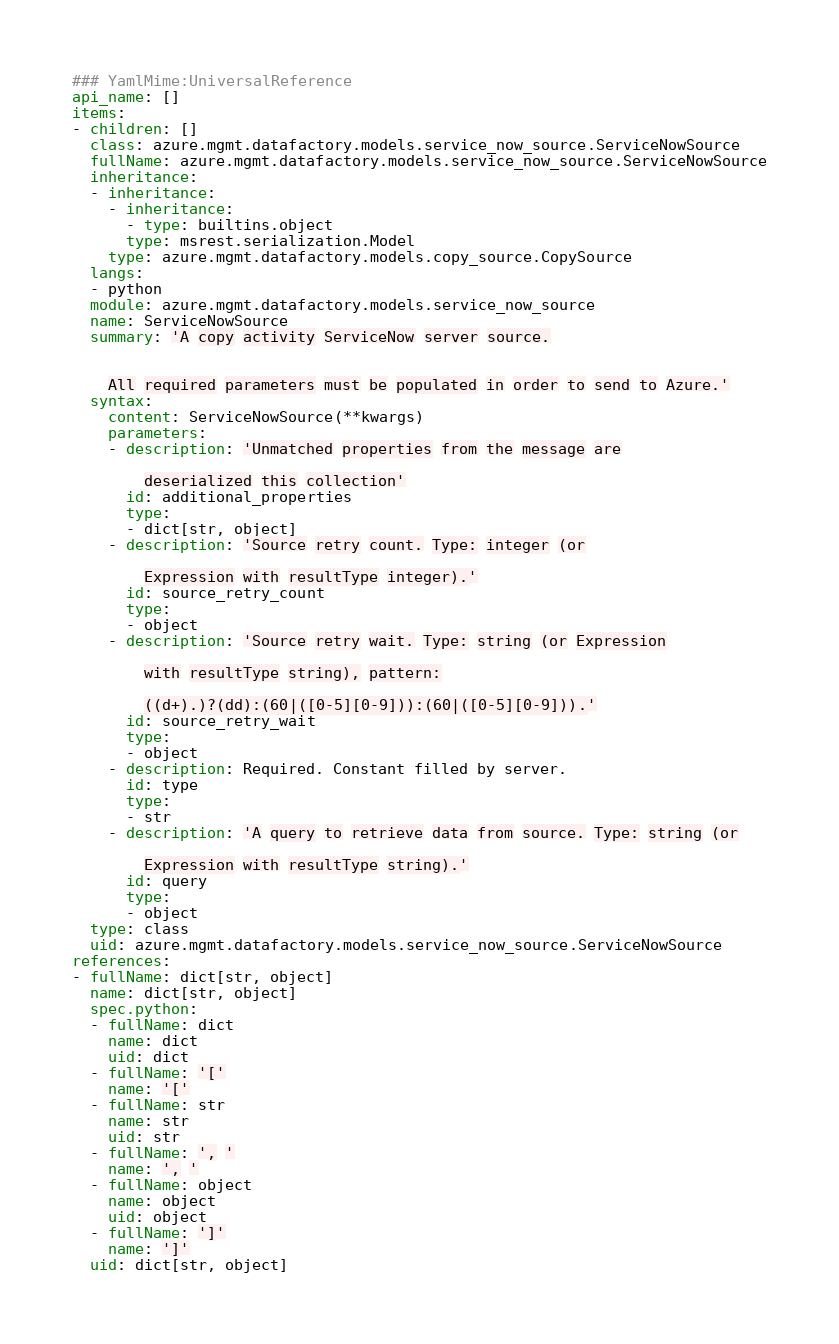<code> <loc_0><loc_0><loc_500><loc_500><_YAML_>### YamlMime:UniversalReference
api_name: []
items:
- children: []
  class: azure.mgmt.datafactory.models.service_now_source.ServiceNowSource
  fullName: azure.mgmt.datafactory.models.service_now_source.ServiceNowSource
  inheritance:
  - inheritance:
    - inheritance:
      - type: builtins.object
      type: msrest.serialization.Model
    type: azure.mgmt.datafactory.models.copy_source.CopySource
  langs:
  - python
  module: azure.mgmt.datafactory.models.service_now_source
  name: ServiceNowSource
  summary: 'A copy activity ServiceNow server source.


    All required parameters must be populated in order to send to Azure.'
  syntax:
    content: ServiceNowSource(**kwargs)
    parameters:
    - description: 'Unmatched properties from the message are

        deserialized this collection'
      id: additional_properties
      type:
      - dict[str, object]
    - description: 'Source retry count. Type: integer (or

        Expression with resultType integer).'
      id: source_retry_count
      type:
      - object
    - description: 'Source retry wait. Type: string (or Expression

        with resultType string), pattern:

        ((d+).)?(dd):(60|([0-5][0-9])):(60|([0-5][0-9])).'
      id: source_retry_wait
      type:
      - object
    - description: Required. Constant filled by server.
      id: type
      type:
      - str
    - description: 'A query to retrieve data from source. Type: string (or

        Expression with resultType string).'
      id: query
      type:
      - object
  type: class
  uid: azure.mgmt.datafactory.models.service_now_source.ServiceNowSource
references:
- fullName: dict[str, object]
  name: dict[str, object]
  spec.python:
  - fullName: dict
    name: dict
    uid: dict
  - fullName: '['
    name: '['
  - fullName: str
    name: str
    uid: str
  - fullName: ', '
    name: ', '
  - fullName: object
    name: object
    uid: object
  - fullName: ']'
    name: ']'
  uid: dict[str, object]
</code> 